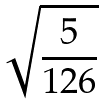<formula> <loc_0><loc_0><loc_500><loc_500>\sqrt { \frac { 5 } { 1 2 6 } }</formula> 